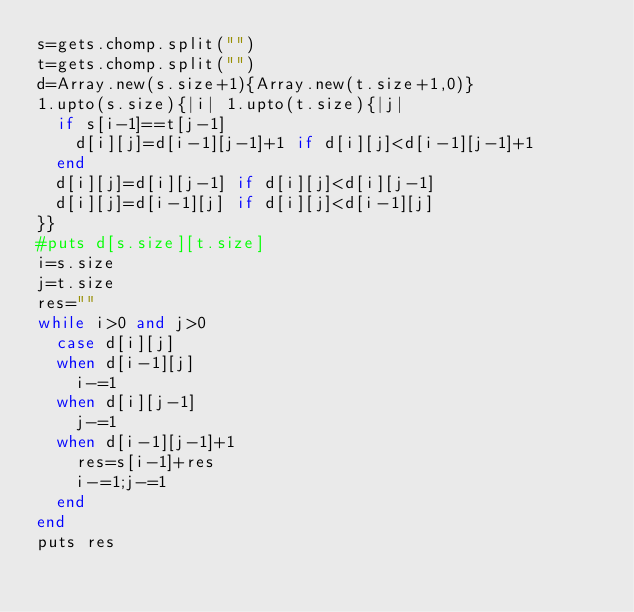<code> <loc_0><loc_0><loc_500><loc_500><_Ruby_>s=gets.chomp.split("")
t=gets.chomp.split("")
d=Array.new(s.size+1){Array.new(t.size+1,0)}
1.upto(s.size){|i| 1.upto(t.size){|j|
  if s[i-1]==t[j-1]
    d[i][j]=d[i-1][j-1]+1 if d[i][j]<d[i-1][j-1]+1
  end
  d[i][j]=d[i][j-1] if d[i][j]<d[i][j-1]
  d[i][j]=d[i-1][j] if d[i][j]<d[i-1][j]
}}
#puts d[s.size][t.size]
i=s.size
j=t.size
res=""
while i>0 and j>0
  case d[i][j]
  when d[i-1][j]
    i-=1
  when d[i][j-1]
    j-=1
  when d[i-1][j-1]+1
    res=s[i-1]+res
    i-=1;j-=1
  end
end
puts res</code> 